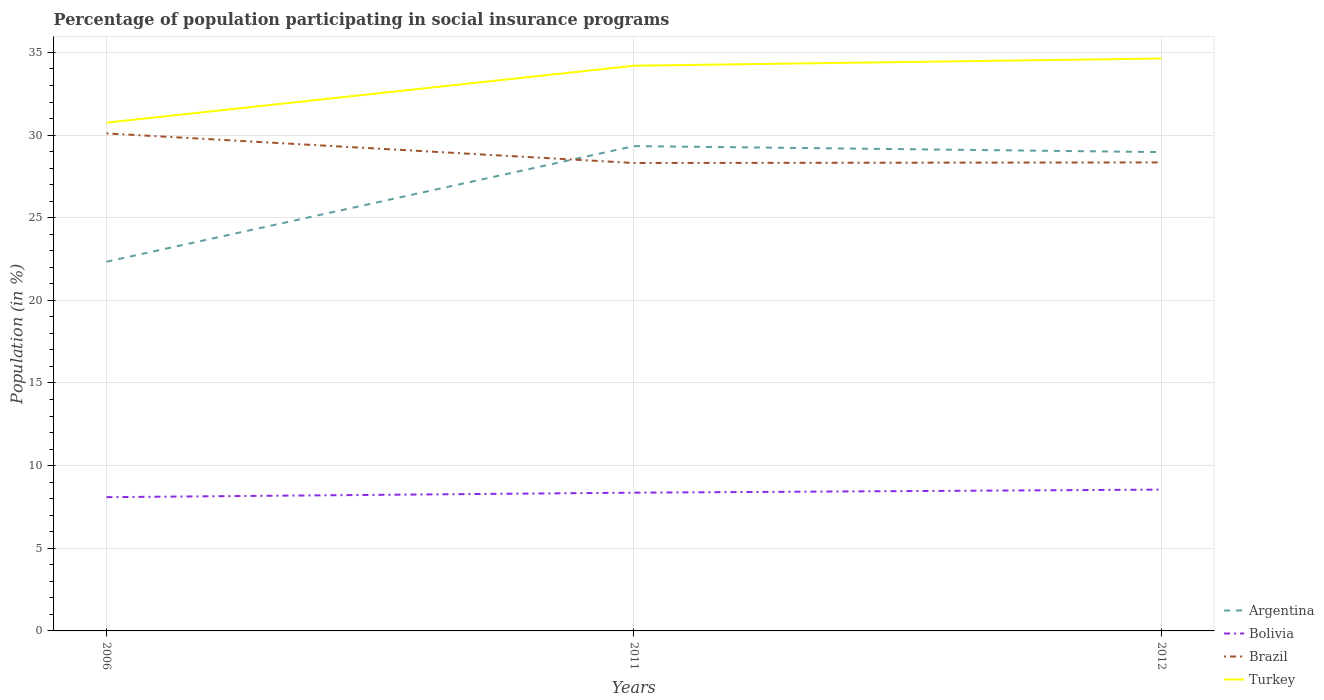Across all years, what is the maximum percentage of population participating in social insurance programs in Bolivia?
Give a very brief answer. 8.09. In which year was the percentage of population participating in social insurance programs in Argentina maximum?
Provide a succinct answer. 2006. What is the total percentage of population participating in social insurance programs in Turkey in the graph?
Ensure brevity in your answer.  -0.44. What is the difference between the highest and the second highest percentage of population participating in social insurance programs in Argentina?
Give a very brief answer. 6.99. What is the difference between the highest and the lowest percentage of population participating in social insurance programs in Bolivia?
Provide a short and direct response. 2. How many lines are there?
Offer a terse response. 4. How many years are there in the graph?
Offer a very short reply. 3. What is the difference between two consecutive major ticks on the Y-axis?
Provide a short and direct response. 5. Does the graph contain any zero values?
Give a very brief answer. No. Does the graph contain grids?
Provide a succinct answer. Yes. What is the title of the graph?
Your answer should be compact. Percentage of population participating in social insurance programs. Does "St. Vincent and the Grenadines" appear as one of the legend labels in the graph?
Provide a succinct answer. No. What is the Population (in %) in Argentina in 2006?
Your answer should be very brief. 22.34. What is the Population (in %) of Bolivia in 2006?
Offer a terse response. 8.09. What is the Population (in %) in Brazil in 2006?
Keep it short and to the point. 30.1. What is the Population (in %) of Turkey in 2006?
Your answer should be very brief. 30.75. What is the Population (in %) in Argentina in 2011?
Provide a short and direct response. 29.33. What is the Population (in %) in Bolivia in 2011?
Provide a short and direct response. 8.36. What is the Population (in %) of Brazil in 2011?
Your response must be concise. 28.31. What is the Population (in %) in Turkey in 2011?
Offer a terse response. 34.2. What is the Population (in %) in Argentina in 2012?
Give a very brief answer. 28.97. What is the Population (in %) of Bolivia in 2012?
Provide a succinct answer. 8.55. What is the Population (in %) of Brazil in 2012?
Offer a terse response. 28.34. What is the Population (in %) of Turkey in 2012?
Your answer should be compact. 34.63. Across all years, what is the maximum Population (in %) in Argentina?
Your answer should be compact. 29.33. Across all years, what is the maximum Population (in %) in Bolivia?
Keep it short and to the point. 8.55. Across all years, what is the maximum Population (in %) in Brazil?
Make the answer very short. 30.1. Across all years, what is the maximum Population (in %) in Turkey?
Provide a succinct answer. 34.63. Across all years, what is the minimum Population (in %) in Argentina?
Keep it short and to the point. 22.34. Across all years, what is the minimum Population (in %) of Bolivia?
Your response must be concise. 8.09. Across all years, what is the minimum Population (in %) in Brazil?
Your response must be concise. 28.31. Across all years, what is the minimum Population (in %) of Turkey?
Offer a terse response. 30.75. What is the total Population (in %) of Argentina in the graph?
Your response must be concise. 80.64. What is the total Population (in %) in Bolivia in the graph?
Keep it short and to the point. 25.01. What is the total Population (in %) of Brazil in the graph?
Make the answer very short. 86.76. What is the total Population (in %) of Turkey in the graph?
Keep it short and to the point. 99.58. What is the difference between the Population (in %) of Argentina in 2006 and that in 2011?
Provide a short and direct response. -6.99. What is the difference between the Population (in %) of Bolivia in 2006 and that in 2011?
Your answer should be very brief. -0.27. What is the difference between the Population (in %) in Brazil in 2006 and that in 2011?
Keep it short and to the point. 1.79. What is the difference between the Population (in %) of Turkey in 2006 and that in 2011?
Provide a succinct answer. -3.45. What is the difference between the Population (in %) in Argentina in 2006 and that in 2012?
Your answer should be very brief. -6.63. What is the difference between the Population (in %) of Bolivia in 2006 and that in 2012?
Your answer should be very brief. -0.46. What is the difference between the Population (in %) of Brazil in 2006 and that in 2012?
Your response must be concise. 1.76. What is the difference between the Population (in %) in Turkey in 2006 and that in 2012?
Your response must be concise. -3.88. What is the difference between the Population (in %) of Argentina in 2011 and that in 2012?
Give a very brief answer. 0.36. What is the difference between the Population (in %) in Bolivia in 2011 and that in 2012?
Your response must be concise. -0.19. What is the difference between the Population (in %) of Brazil in 2011 and that in 2012?
Provide a succinct answer. -0.03. What is the difference between the Population (in %) in Turkey in 2011 and that in 2012?
Provide a short and direct response. -0.44. What is the difference between the Population (in %) in Argentina in 2006 and the Population (in %) in Bolivia in 2011?
Your answer should be very brief. 13.97. What is the difference between the Population (in %) of Argentina in 2006 and the Population (in %) of Brazil in 2011?
Provide a succinct answer. -5.97. What is the difference between the Population (in %) in Argentina in 2006 and the Population (in %) in Turkey in 2011?
Your response must be concise. -11.86. What is the difference between the Population (in %) of Bolivia in 2006 and the Population (in %) of Brazil in 2011?
Make the answer very short. -20.22. What is the difference between the Population (in %) of Bolivia in 2006 and the Population (in %) of Turkey in 2011?
Your answer should be compact. -26.1. What is the difference between the Population (in %) in Brazil in 2006 and the Population (in %) in Turkey in 2011?
Offer a terse response. -4.09. What is the difference between the Population (in %) in Argentina in 2006 and the Population (in %) in Bolivia in 2012?
Offer a very short reply. 13.79. What is the difference between the Population (in %) in Argentina in 2006 and the Population (in %) in Brazil in 2012?
Offer a very short reply. -6.01. What is the difference between the Population (in %) in Argentina in 2006 and the Population (in %) in Turkey in 2012?
Keep it short and to the point. -12.29. What is the difference between the Population (in %) of Bolivia in 2006 and the Population (in %) of Brazil in 2012?
Offer a very short reply. -20.25. What is the difference between the Population (in %) of Bolivia in 2006 and the Population (in %) of Turkey in 2012?
Ensure brevity in your answer.  -26.54. What is the difference between the Population (in %) of Brazil in 2006 and the Population (in %) of Turkey in 2012?
Offer a very short reply. -4.53. What is the difference between the Population (in %) in Argentina in 2011 and the Population (in %) in Bolivia in 2012?
Your answer should be compact. 20.78. What is the difference between the Population (in %) of Argentina in 2011 and the Population (in %) of Brazil in 2012?
Your response must be concise. 0.99. What is the difference between the Population (in %) of Argentina in 2011 and the Population (in %) of Turkey in 2012?
Offer a terse response. -5.3. What is the difference between the Population (in %) in Bolivia in 2011 and the Population (in %) in Brazil in 2012?
Your answer should be very brief. -19.98. What is the difference between the Population (in %) of Bolivia in 2011 and the Population (in %) of Turkey in 2012?
Offer a terse response. -26.27. What is the difference between the Population (in %) of Brazil in 2011 and the Population (in %) of Turkey in 2012?
Provide a short and direct response. -6.32. What is the average Population (in %) of Argentina per year?
Your response must be concise. 26.88. What is the average Population (in %) in Bolivia per year?
Keep it short and to the point. 8.34. What is the average Population (in %) of Brazil per year?
Ensure brevity in your answer.  28.92. What is the average Population (in %) of Turkey per year?
Make the answer very short. 33.19. In the year 2006, what is the difference between the Population (in %) in Argentina and Population (in %) in Bolivia?
Your response must be concise. 14.25. In the year 2006, what is the difference between the Population (in %) in Argentina and Population (in %) in Brazil?
Give a very brief answer. -7.76. In the year 2006, what is the difference between the Population (in %) in Argentina and Population (in %) in Turkey?
Provide a short and direct response. -8.41. In the year 2006, what is the difference between the Population (in %) in Bolivia and Population (in %) in Brazil?
Your answer should be very brief. -22.01. In the year 2006, what is the difference between the Population (in %) of Bolivia and Population (in %) of Turkey?
Provide a succinct answer. -22.66. In the year 2006, what is the difference between the Population (in %) in Brazil and Population (in %) in Turkey?
Keep it short and to the point. -0.65. In the year 2011, what is the difference between the Population (in %) in Argentina and Population (in %) in Bolivia?
Your answer should be compact. 20.97. In the year 2011, what is the difference between the Population (in %) of Argentina and Population (in %) of Brazil?
Your answer should be compact. 1.02. In the year 2011, what is the difference between the Population (in %) of Argentina and Population (in %) of Turkey?
Offer a very short reply. -4.86. In the year 2011, what is the difference between the Population (in %) of Bolivia and Population (in %) of Brazil?
Provide a short and direct response. -19.95. In the year 2011, what is the difference between the Population (in %) in Bolivia and Population (in %) in Turkey?
Your response must be concise. -25.83. In the year 2011, what is the difference between the Population (in %) in Brazil and Population (in %) in Turkey?
Make the answer very short. -5.88. In the year 2012, what is the difference between the Population (in %) of Argentina and Population (in %) of Bolivia?
Keep it short and to the point. 20.42. In the year 2012, what is the difference between the Population (in %) in Argentina and Population (in %) in Brazil?
Your answer should be compact. 0.62. In the year 2012, what is the difference between the Population (in %) in Argentina and Population (in %) in Turkey?
Give a very brief answer. -5.66. In the year 2012, what is the difference between the Population (in %) of Bolivia and Population (in %) of Brazil?
Your answer should be very brief. -19.79. In the year 2012, what is the difference between the Population (in %) of Bolivia and Population (in %) of Turkey?
Provide a succinct answer. -26.08. In the year 2012, what is the difference between the Population (in %) of Brazil and Population (in %) of Turkey?
Your response must be concise. -6.29. What is the ratio of the Population (in %) in Argentina in 2006 to that in 2011?
Ensure brevity in your answer.  0.76. What is the ratio of the Population (in %) in Bolivia in 2006 to that in 2011?
Keep it short and to the point. 0.97. What is the ratio of the Population (in %) of Brazil in 2006 to that in 2011?
Your answer should be compact. 1.06. What is the ratio of the Population (in %) of Turkey in 2006 to that in 2011?
Your response must be concise. 0.9. What is the ratio of the Population (in %) of Argentina in 2006 to that in 2012?
Your response must be concise. 0.77. What is the ratio of the Population (in %) in Bolivia in 2006 to that in 2012?
Your answer should be very brief. 0.95. What is the ratio of the Population (in %) in Brazil in 2006 to that in 2012?
Your answer should be very brief. 1.06. What is the ratio of the Population (in %) of Turkey in 2006 to that in 2012?
Keep it short and to the point. 0.89. What is the ratio of the Population (in %) in Argentina in 2011 to that in 2012?
Keep it short and to the point. 1.01. What is the ratio of the Population (in %) of Bolivia in 2011 to that in 2012?
Offer a terse response. 0.98. What is the ratio of the Population (in %) of Brazil in 2011 to that in 2012?
Provide a short and direct response. 1. What is the ratio of the Population (in %) in Turkey in 2011 to that in 2012?
Make the answer very short. 0.99. What is the difference between the highest and the second highest Population (in %) in Argentina?
Your answer should be very brief. 0.36. What is the difference between the highest and the second highest Population (in %) of Bolivia?
Ensure brevity in your answer.  0.19. What is the difference between the highest and the second highest Population (in %) of Brazil?
Keep it short and to the point. 1.76. What is the difference between the highest and the second highest Population (in %) of Turkey?
Keep it short and to the point. 0.44. What is the difference between the highest and the lowest Population (in %) of Argentina?
Your response must be concise. 6.99. What is the difference between the highest and the lowest Population (in %) of Bolivia?
Ensure brevity in your answer.  0.46. What is the difference between the highest and the lowest Population (in %) of Brazil?
Provide a short and direct response. 1.79. What is the difference between the highest and the lowest Population (in %) in Turkey?
Your response must be concise. 3.88. 